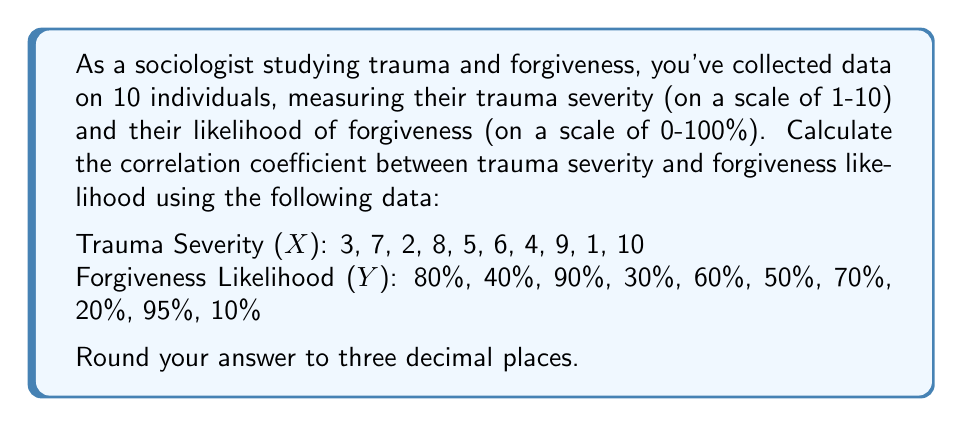Can you answer this question? To calculate the correlation coefficient, we'll use the Pearson correlation coefficient formula:

$$ r = \frac{\sum_{i=1}^{n} (x_i - \bar{x})(y_i - \bar{y})}{\sqrt{\sum_{i=1}^{n} (x_i - \bar{x})^2 \sum_{i=1}^{n} (y_i - \bar{y})^2}} $$

Where:
$r$ is the correlation coefficient
$x_i$ and $y_i$ are the individual sample points
$\bar{x}$ and $\bar{y}$ are the sample means

Step 1: Calculate the means
$\bar{x} = \frac{3 + 7 + 2 + 8 + 5 + 6 + 4 + 9 + 1 + 10}{10} = 5.5$
$\bar{y} = \frac{80 + 40 + 90 + 30 + 60 + 50 + 70 + 20 + 95 + 10}{10} = 54.5$

Step 2: Calculate $(x_i - \bar{x})$, $(y_i - \bar{y})$, $(x_i - \bar{x})^2$, $(y_i - \bar{y})^2$, and $(x_i - \bar{x})(y_i - \bar{y})$ for each data point.

Step 3: Sum up the values calculated in Step 2:
$\sum (x_i - \bar{x})(y_i - \bar{y}) = -1023.75$
$\sum (x_i - \bar{x})^2 = 82.5$
$\sum (y_i - \bar{y})^2 = 7612.25$

Step 4: Apply the correlation coefficient formula:

$$ r = \frac{-1023.75}{\sqrt{82.5 \times 7612.25}} = \frac{-1023.75}{792.3831} = -0.2915 $$

Rounding to three decimal places gives us -0.292.
Answer: -0.292 